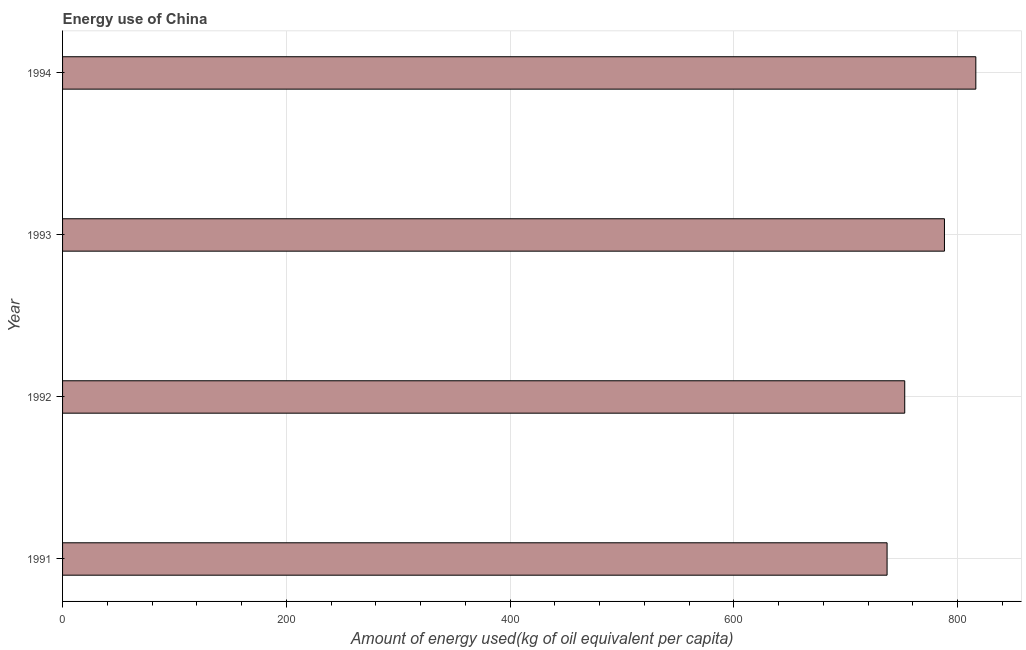What is the title of the graph?
Give a very brief answer. Energy use of China. What is the label or title of the X-axis?
Your answer should be very brief. Amount of energy used(kg of oil equivalent per capita). What is the amount of energy used in 1991?
Your response must be concise. 736.85. Across all years, what is the maximum amount of energy used?
Offer a very short reply. 816.16. Across all years, what is the minimum amount of energy used?
Offer a very short reply. 736.85. What is the sum of the amount of energy used?
Offer a very short reply. 3093.77. What is the difference between the amount of energy used in 1992 and 1993?
Provide a succinct answer. -35.5. What is the average amount of energy used per year?
Make the answer very short. 773.44. What is the median amount of energy used?
Your response must be concise. 770.38. Do a majority of the years between 1991 and 1992 (inclusive) have amount of energy used greater than 240 kg?
Provide a short and direct response. Yes. What is the ratio of the amount of energy used in 1992 to that in 1994?
Your answer should be very brief. 0.92. Is the amount of energy used in 1991 less than that in 1992?
Keep it short and to the point. Yes. Is the difference between the amount of energy used in 1993 and 1994 greater than the difference between any two years?
Make the answer very short. No. What is the difference between the highest and the second highest amount of energy used?
Keep it short and to the point. 28.03. What is the difference between the highest and the lowest amount of energy used?
Your answer should be compact. 79.31. In how many years, is the amount of energy used greater than the average amount of energy used taken over all years?
Offer a very short reply. 2. How many bars are there?
Your answer should be compact. 4. Are all the bars in the graph horizontal?
Provide a succinct answer. Yes. How many years are there in the graph?
Your answer should be compact. 4. What is the difference between two consecutive major ticks on the X-axis?
Your response must be concise. 200. Are the values on the major ticks of X-axis written in scientific E-notation?
Ensure brevity in your answer.  No. What is the Amount of energy used(kg of oil equivalent per capita) of 1991?
Give a very brief answer. 736.85. What is the Amount of energy used(kg of oil equivalent per capita) in 1992?
Offer a terse response. 752.63. What is the Amount of energy used(kg of oil equivalent per capita) of 1993?
Offer a very short reply. 788.13. What is the Amount of energy used(kg of oil equivalent per capita) of 1994?
Offer a terse response. 816.16. What is the difference between the Amount of energy used(kg of oil equivalent per capita) in 1991 and 1992?
Keep it short and to the point. -15.78. What is the difference between the Amount of energy used(kg of oil equivalent per capita) in 1991 and 1993?
Provide a short and direct response. -51.28. What is the difference between the Amount of energy used(kg of oil equivalent per capita) in 1991 and 1994?
Keep it short and to the point. -79.31. What is the difference between the Amount of energy used(kg of oil equivalent per capita) in 1992 and 1993?
Provide a succinct answer. -35.5. What is the difference between the Amount of energy used(kg of oil equivalent per capita) in 1992 and 1994?
Offer a terse response. -63.53. What is the difference between the Amount of energy used(kg of oil equivalent per capita) in 1993 and 1994?
Offer a very short reply. -28.03. What is the ratio of the Amount of energy used(kg of oil equivalent per capita) in 1991 to that in 1993?
Provide a short and direct response. 0.94. What is the ratio of the Amount of energy used(kg of oil equivalent per capita) in 1991 to that in 1994?
Keep it short and to the point. 0.9. What is the ratio of the Amount of energy used(kg of oil equivalent per capita) in 1992 to that in 1993?
Provide a short and direct response. 0.95. What is the ratio of the Amount of energy used(kg of oil equivalent per capita) in 1992 to that in 1994?
Ensure brevity in your answer.  0.92. What is the ratio of the Amount of energy used(kg of oil equivalent per capita) in 1993 to that in 1994?
Your response must be concise. 0.97. 